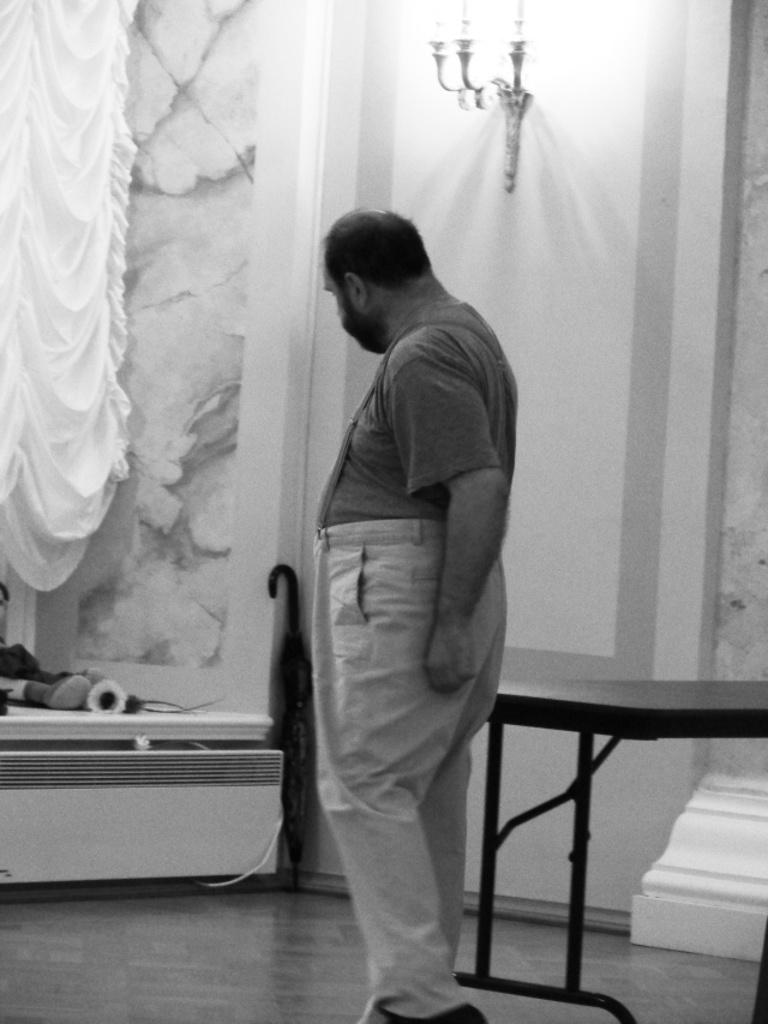Who is present in the image? There is a man in the image. What can be seen on the wall in the image? There is a lamp on the wall in the image. What piece of furniture is in the image? There is a table in the image. What type of window treatment is present in the image? There is a curtain in the image. What is placed on the table in the image? There are objects placed on the table. What type of beam is being used to generate profit in the image? There is no beam or mention of profit in the image; it features a man, a lamp, a table, a curtain, and objects on the table. 